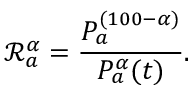Convert formula to latex. <formula><loc_0><loc_0><loc_500><loc_500>\mathcal { R } _ { a } ^ { \alpha } = \frac { P _ { a } ^ { ( 1 0 0 - \alpha ) } } { P _ { a } ^ { \alpha } ( t ) } .</formula> 